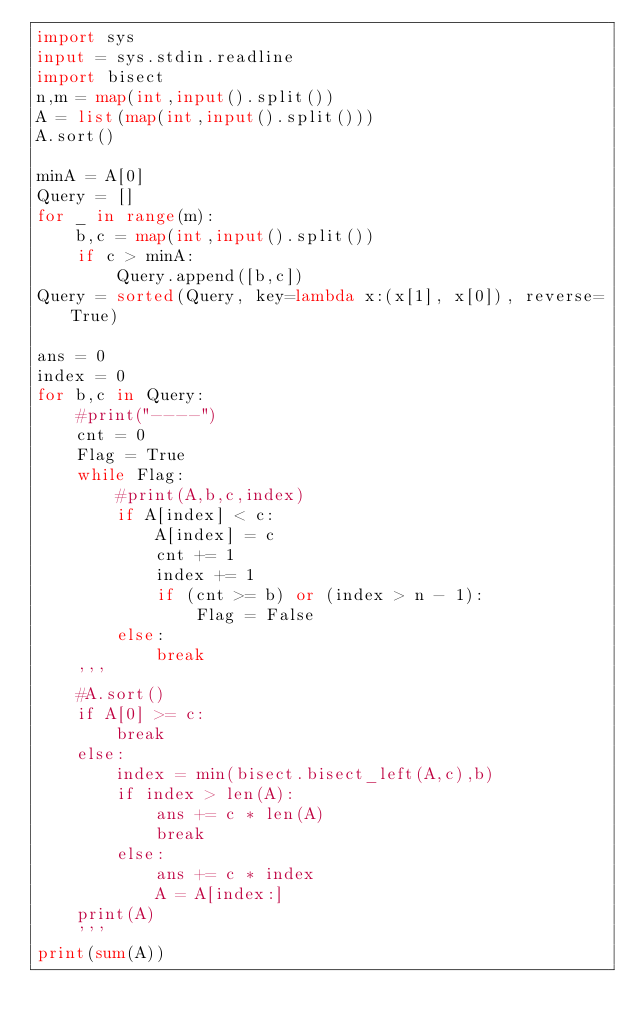Convert code to text. <code><loc_0><loc_0><loc_500><loc_500><_Python_>import sys
input = sys.stdin.readline
import bisect
n,m = map(int,input().split())
A = list(map(int,input().split()))
A.sort()

minA = A[0]
Query = []
for _ in range(m):
    b,c = map(int,input().split())
    if c > minA:
        Query.append([b,c])
Query = sorted(Query, key=lambda x:(x[1], x[0]), reverse=True)

ans = 0
index = 0
for b,c in Query:
    #print("----")
    cnt = 0
    Flag = True
    while Flag:
        #print(A,b,c,index)
        if A[index] < c:
            A[index] = c
            cnt += 1
            index += 1
            if (cnt >= b) or (index > n - 1):
                Flag = False
        else:
            break
    '''
    #A.sort()
    if A[0] >= c:
        break
    else:
        index = min(bisect.bisect_left(A,c),b)
        if index > len(A):
            ans += c * len(A)
            break
        else:
            ans += c * index
            A = A[index:]
    print(A)
    '''
print(sum(A))</code> 